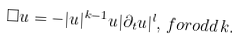Convert formula to latex. <formula><loc_0><loc_0><loc_500><loc_500>\Box u = - | u | ^ { k - 1 } u | \partial _ { t } u | ^ { l } , \, f o r o d d \, k .</formula> 